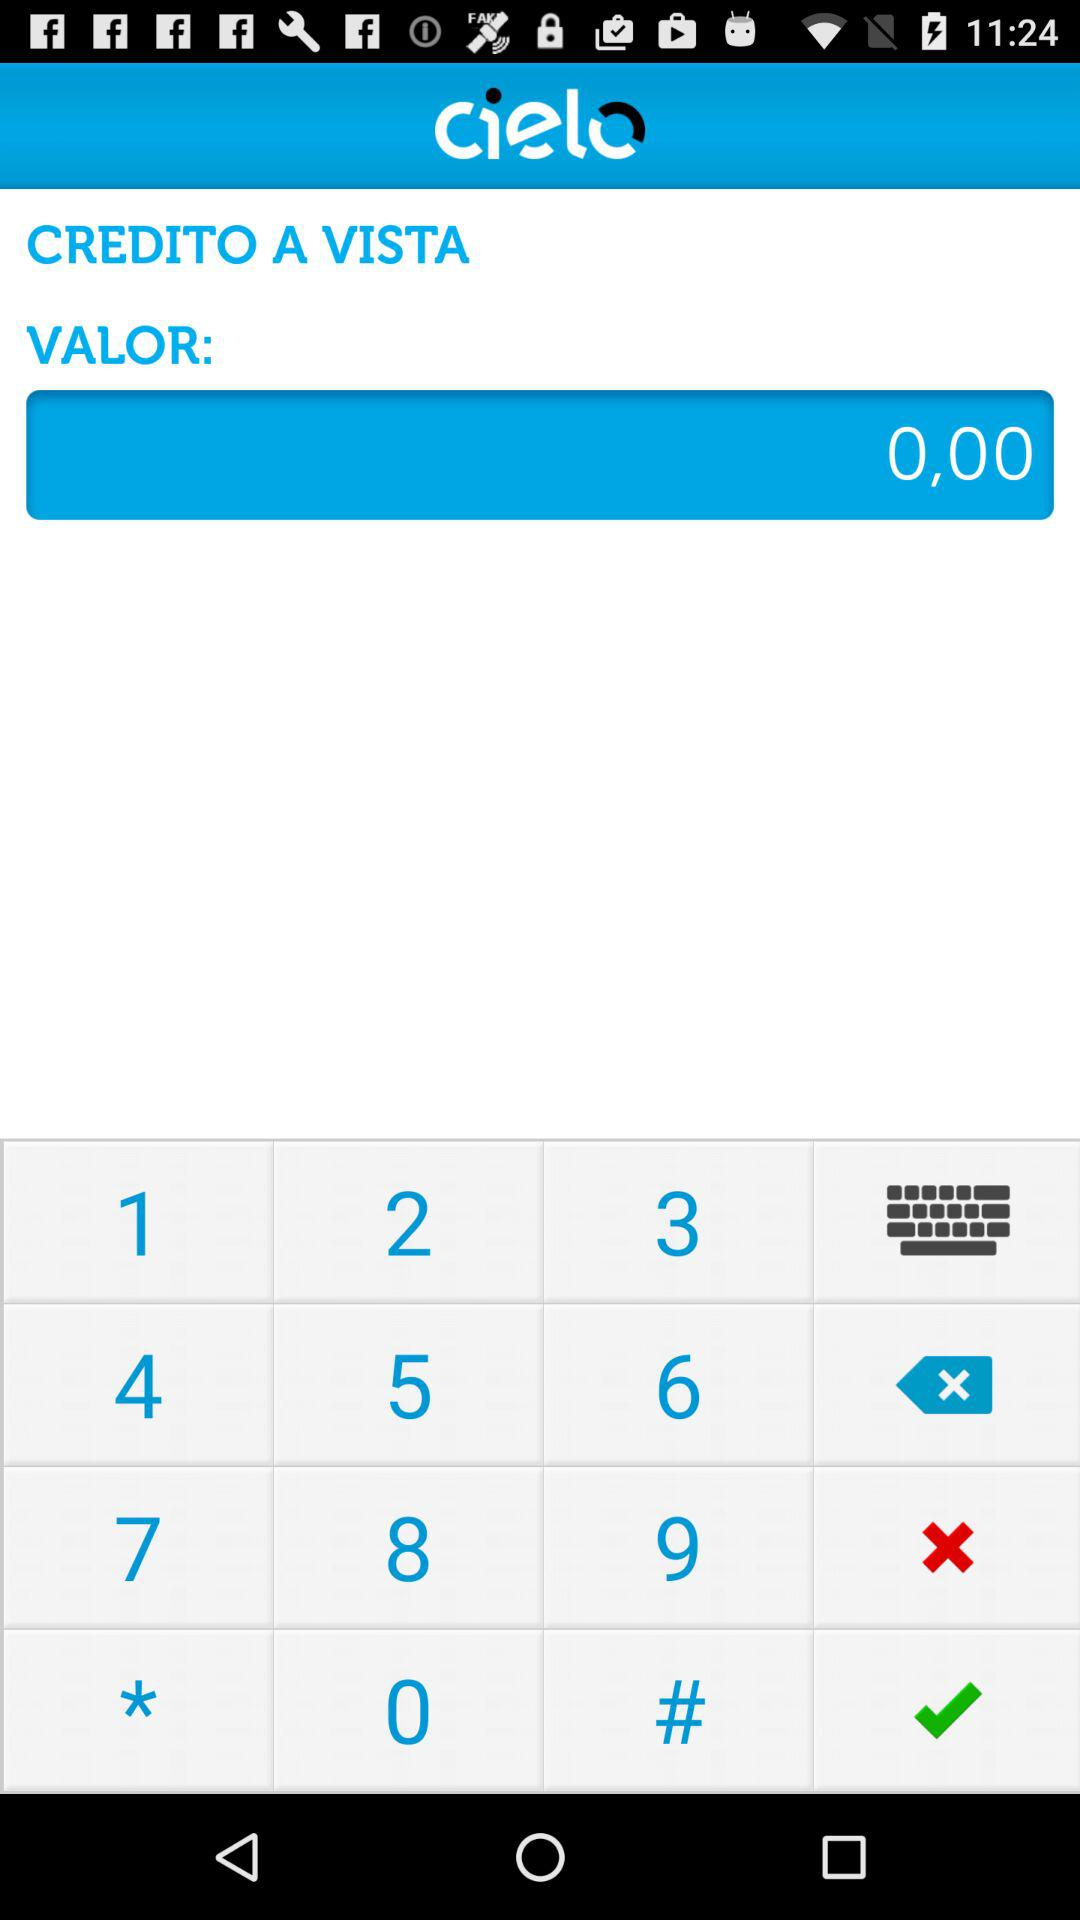How much is the value of the credit?
Answer the question using a single word or phrase. 0,00 